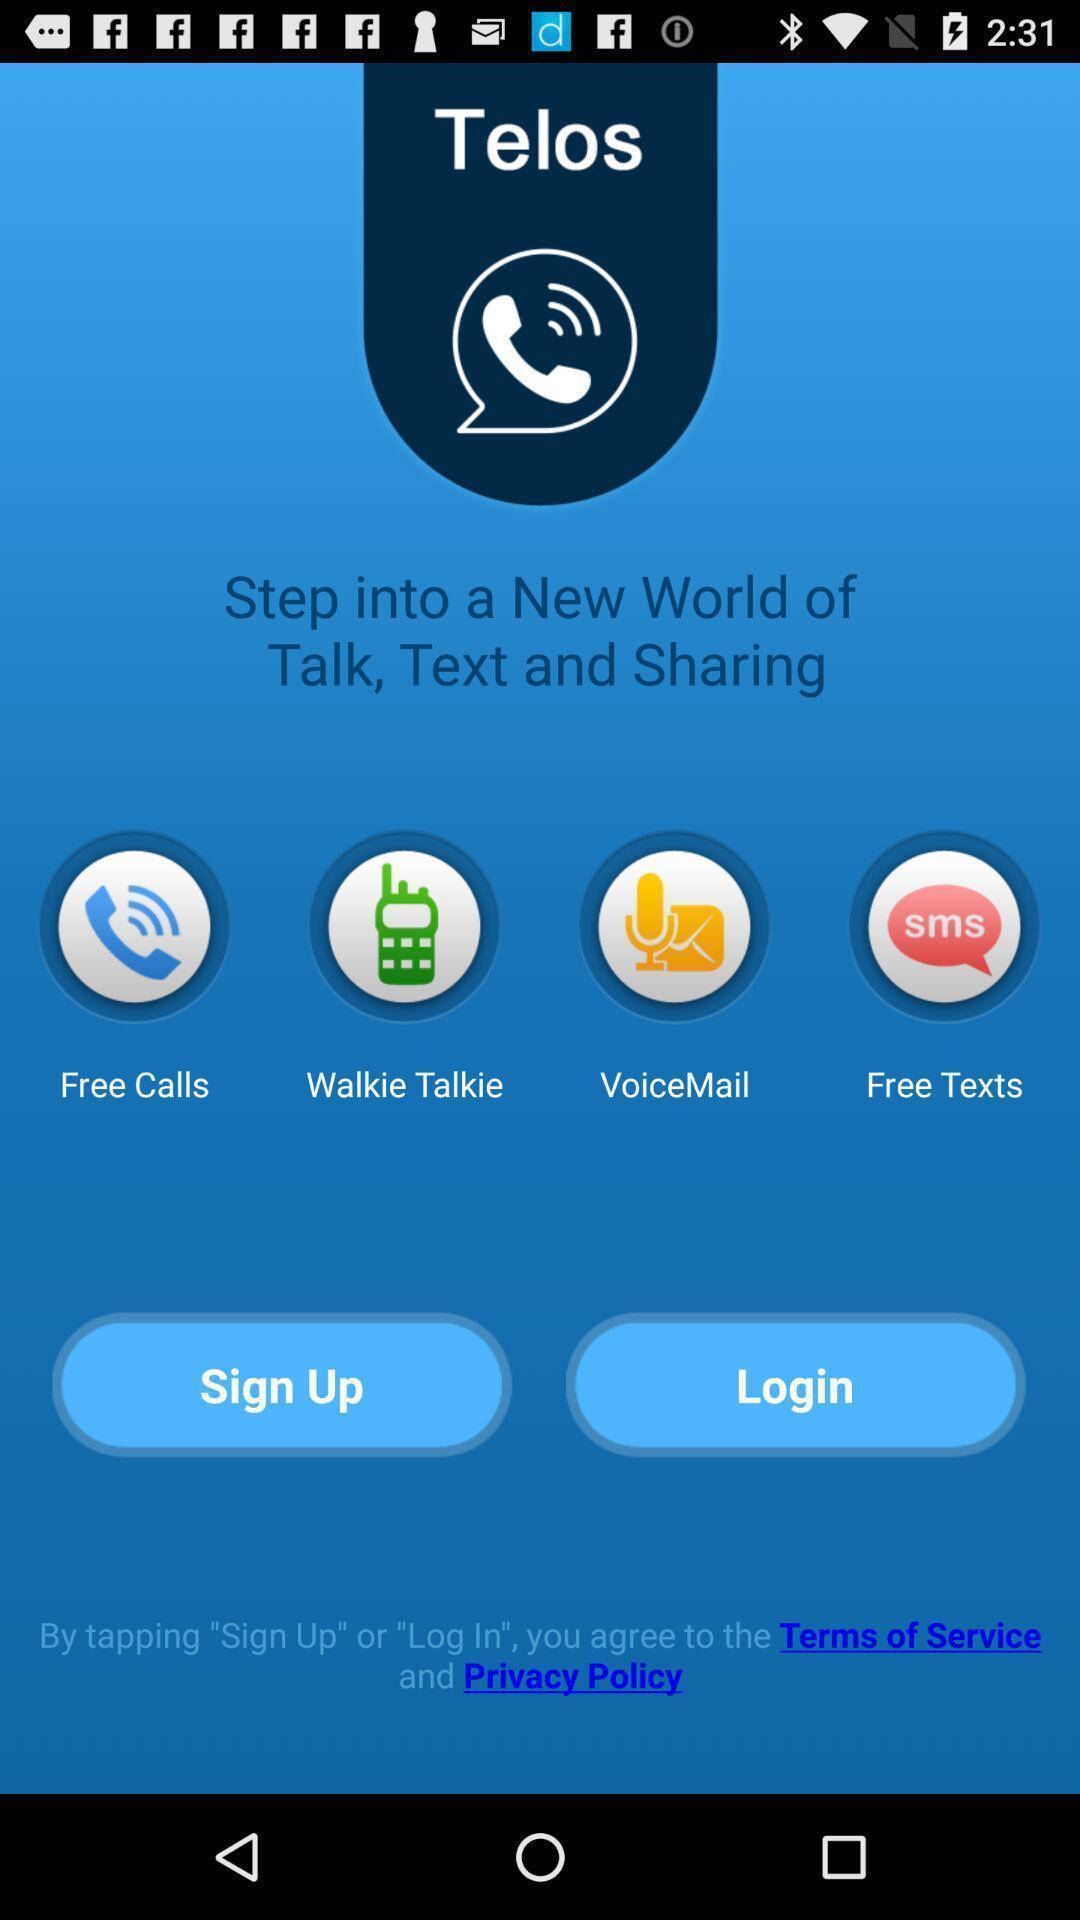Provide a detailed account of this screenshot. Welcome page of a calling app. 